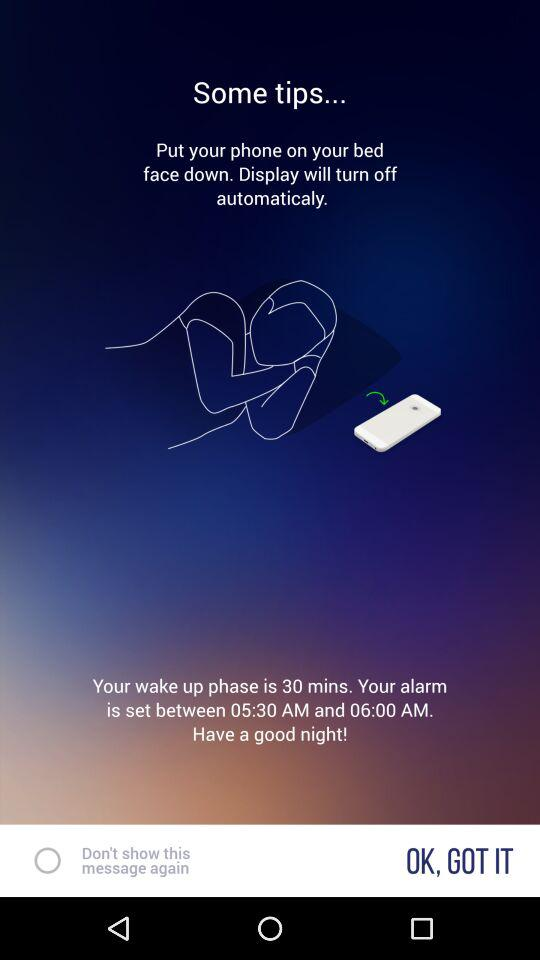How many more minutes is the wake up phase than the alarm is set for?
Answer the question using a single word or phrase. 30 